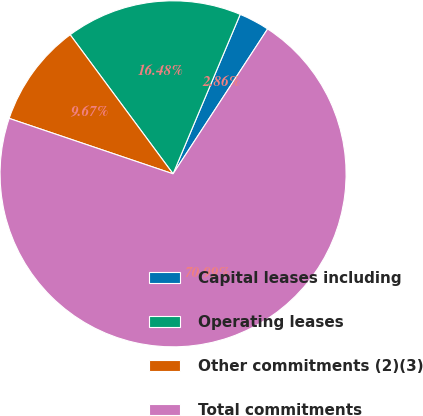Convert chart to OTSL. <chart><loc_0><loc_0><loc_500><loc_500><pie_chart><fcel>Capital leases including<fcel>Operating leases<fcel>Other commitments (2)(3)<fcel>Total commitments<nl><fcel>2.86%<fcel>16.48%<fcel>9.67%<fcel>70.99%<nl></chart> 